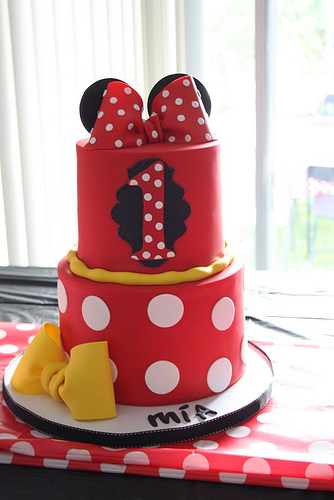<image>
Can you confirm if the bow is on the cake? Yes. Looking at the image, I can see the bow is positioned on top of the cake, with the cake providing support. 